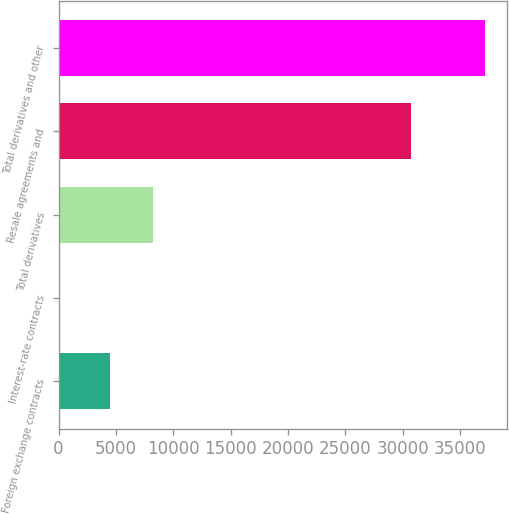<chart> <loc_0><loc_0><loc_500><loc_500><bar_chart><fcel>Foreign exchange contracts<fcel>Interest-rate contracts<fcel>Total derivatives<fcel>Resale agreements and<fcel>Total derivatives and other<nl><fcel>4514<fcel>59<fcel>8228.2<fcel>30700<fcel>37201<nl></chart> 